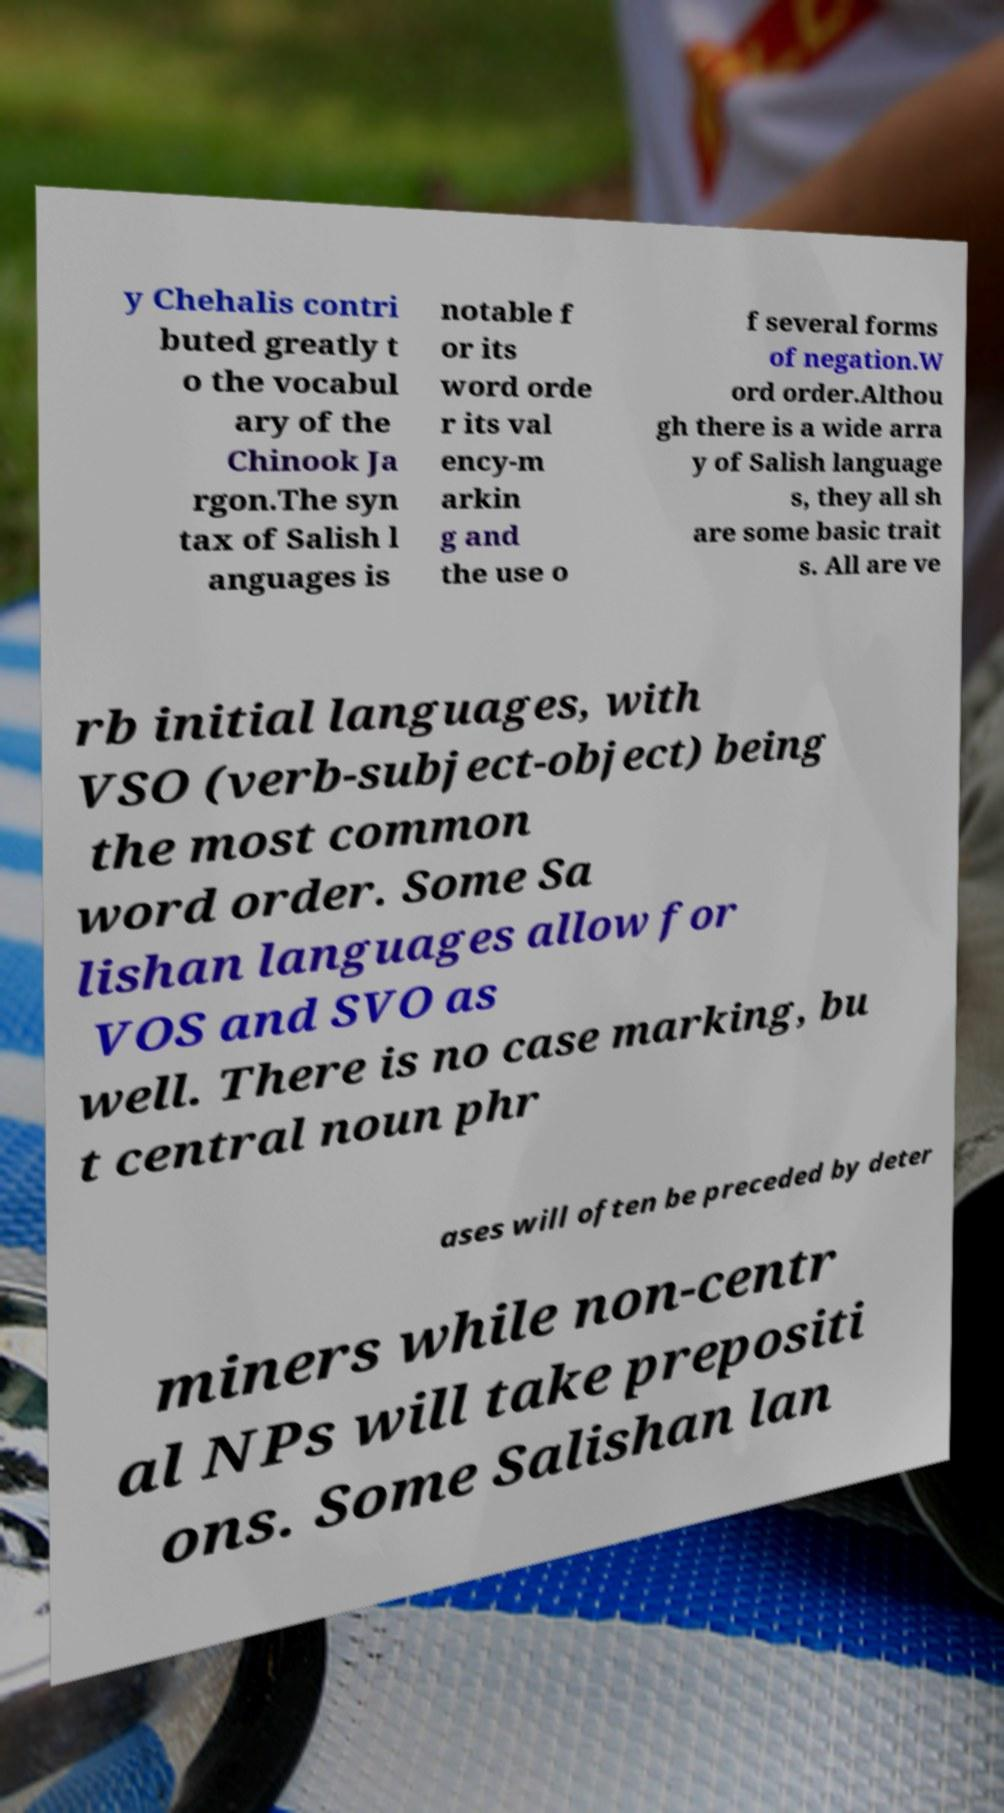There's text embedded in this image that I need extracted. Can you transcribe it verbatim? y Chehalis contri buted greatly t o the vocabul ary of the Chinook Ja rgon.The syn tax of Salish l anguages is notable f or its word orde r its val ency-m arkin g and the use o f several forms of negation.W ord order.Althou gh there is a wide arra y of Salish language s, they all sh are some basic trait s. All are ve rb initial languages, with VSO (verb-subject-object) being the most common word order. Some Sa lishan languages allow for VOS and SVO as well. There is no case marking, bu t central noun phr ases will often be preceded by deter miners while non-centr al NPs will take prepositi ons. Some Salishan lan 